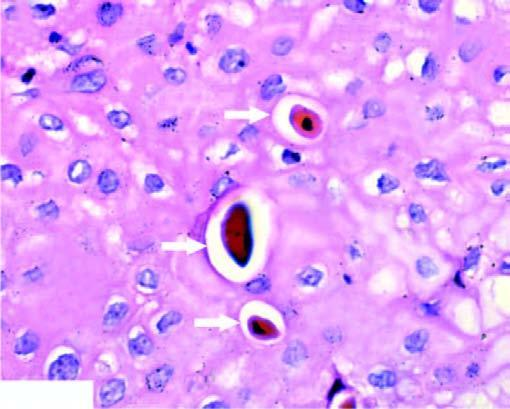what is there?
Answer the question using a single word or phrase. No inflammation 